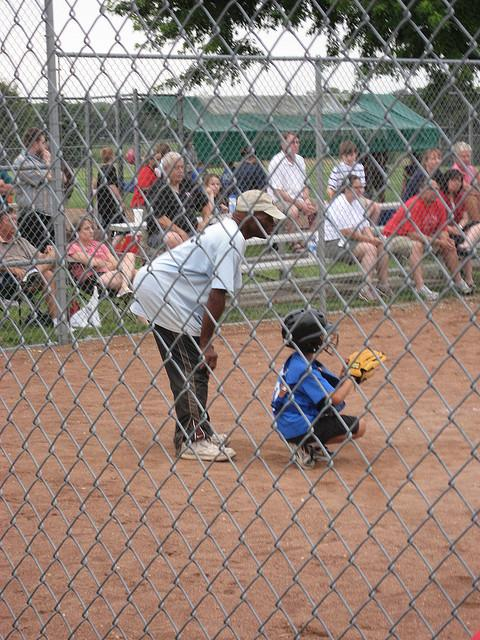How are the people in the stands here likely related to the players on the field here? Please explain your reasoning. relatives. This is a baseball game for kids which is usually watched by families. 